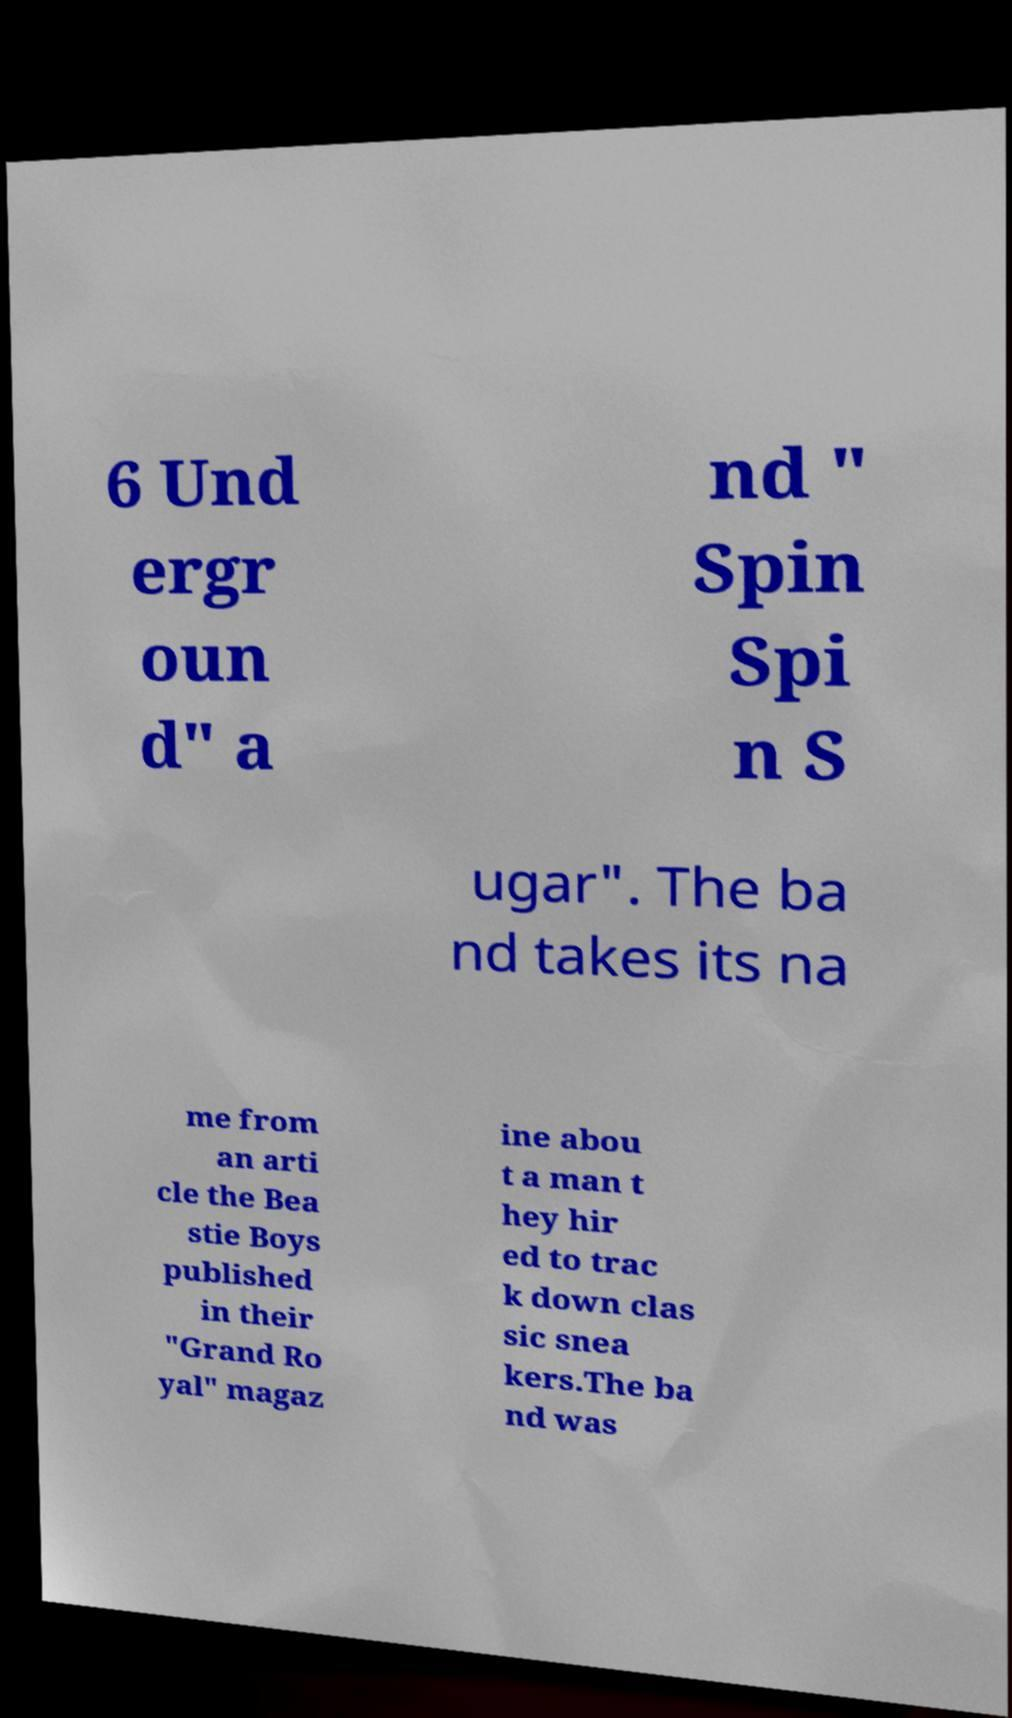I need the written content from this picture converted into text. Can you do that? 6 Und ergr oun d" a nd " Spin Spi n S ugar". The ba nd takes its na me from an arti cle the Bea stie Boys published in their "Grand Ro yal" magaz ine abou t a man t hey hir ed to trac k down clas sic snea kers.The ba nd was 